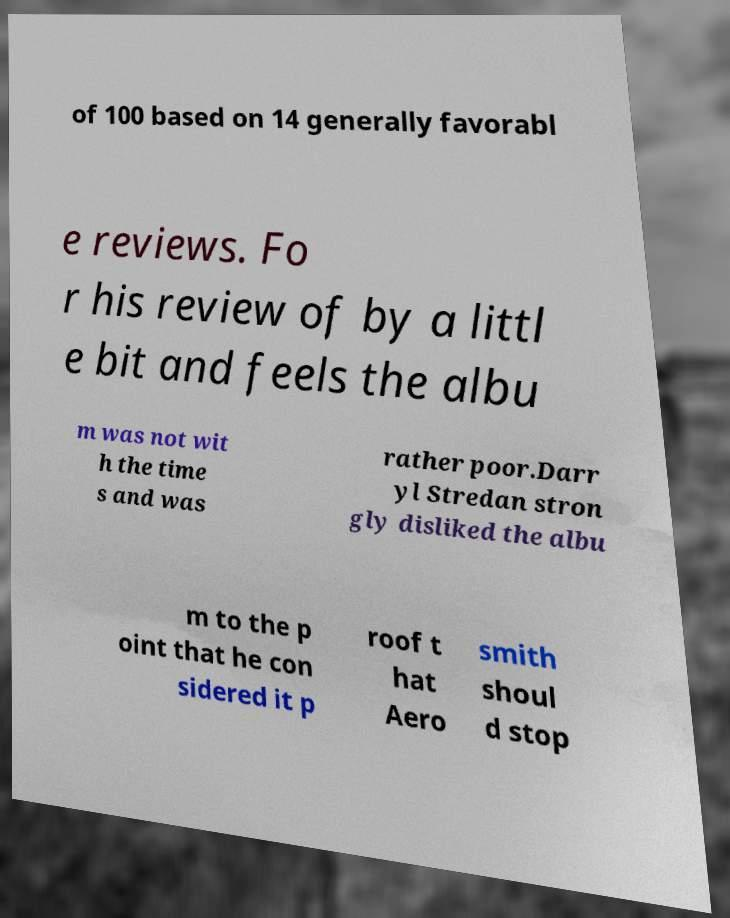Could you assist in decoding the text presented in this image and type it out clearly? of 100 based on 14 generally favorabl e reviews. Fo r his review of by a littl e bit and feels the albu m was not wit h the time s and was rather poor.Darr yl Stredan stron gly disliked the albu m to the p oint that he con sidered it p roof t hat Aero smith shoul d stop 